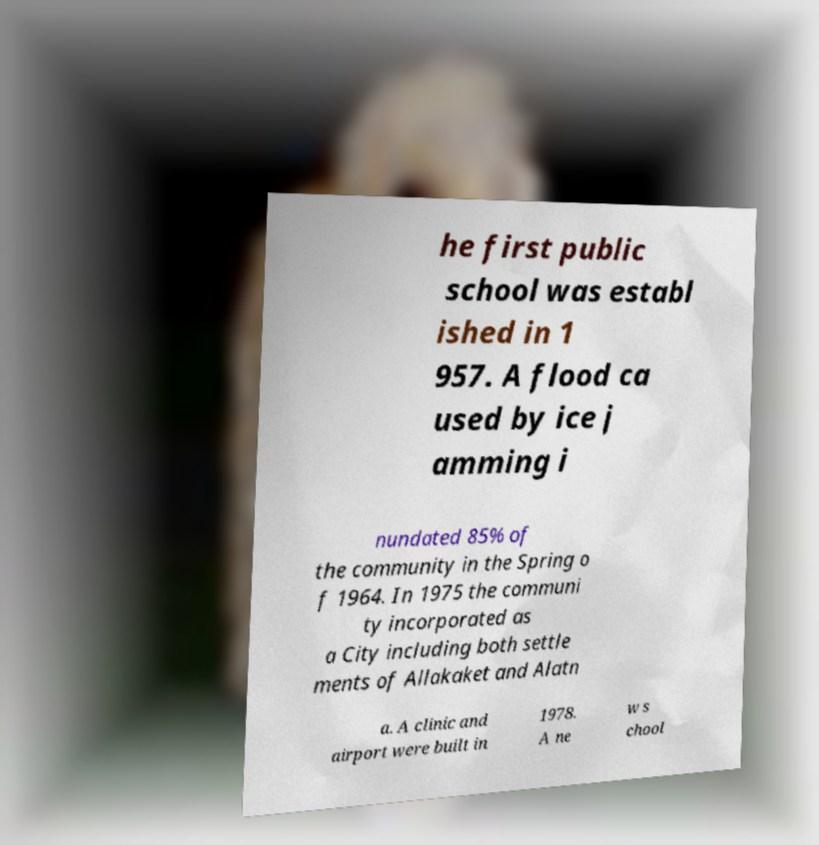There's text embedded in this image that I need extracted. Can you transcribe it verbatim? he first public school was establ ished in 1 957. A flood ca used by ice j amming i nundated 85% of the community in the Spring o f 1964. In 1975 the communi ty incorporated as a City including both settle ments of Allakaket and Alatn a. A clinic and airport were built in 1978. A ne w s chool 